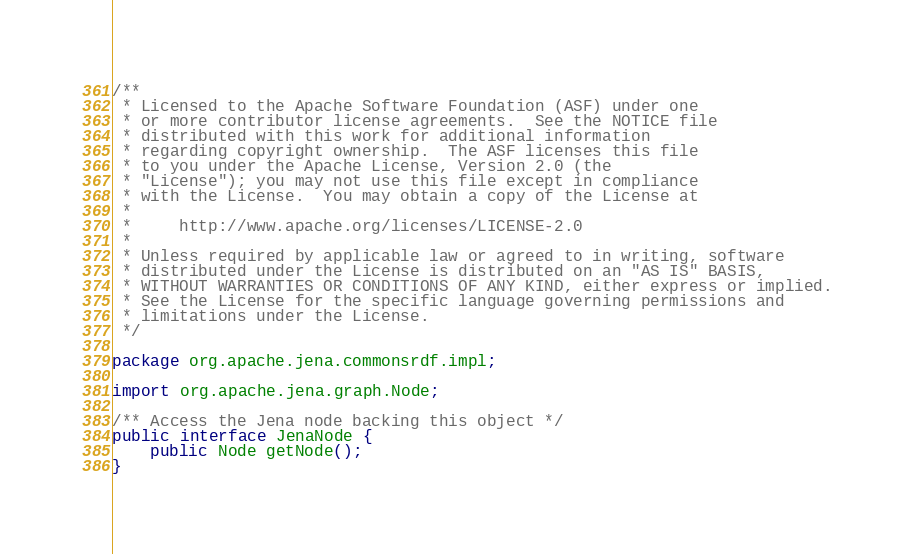<code> <loc_0><loc_0><loc_500><loc_500><_Java_>/**
 * Licensed to the Apache Software Foundation (ASF) under one
 * or more contributor license agreements.  See the NOTICE file
 * distributed with this work for additional information
 * regarding copyright ownership.  The ASF licenses this file
 * to you under the Apache License, Version 2.0 (the
 * "License"); you may not use this file except in compliance
 * with the License.  You may obtain a copy of the License at
 *
 *     http://www.apache.org/licenses/LICENSE-2.0
 *
 * Unless required by applicable law or agreed to in writing, software
 * distributed under the License is distributed on an "AS IS" BASIS,
 * WITHOUT WARRANTIES OR CONDITIONS OF ANY KIND, either express or implied.
 * See the License for the specific language governing permissions and
 * limitations under the License.
 */

package org.apache.jena.commonsrdf.impl;

import org.apache.jena.graph.Node;

/** Access the Jena node backing this object */
public interface JenaNode {
    public Node getNode();
}
</code> 